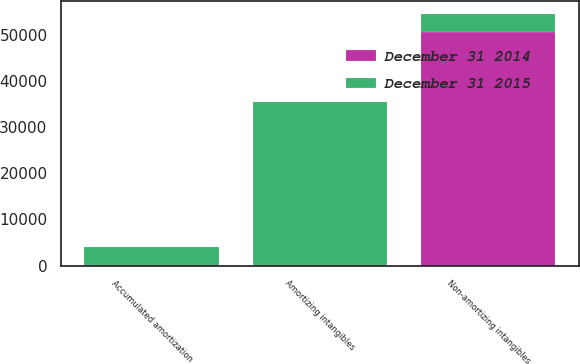Convert chart. <chart><loc_0><loc_0><loc_500><loc_500><stacked_bar_chart><ecel><fcel>Amortizing intangibles<fcel>Accumulated amortization<fcel>Non-amortizing intangibles<nl><fcel>December 31 2015<fcel>35263<fcel>3899<fcel>3899<nl><fcel>December 31 2014<fcel>233<fcel>50<fcel>50565<nl></chart> 